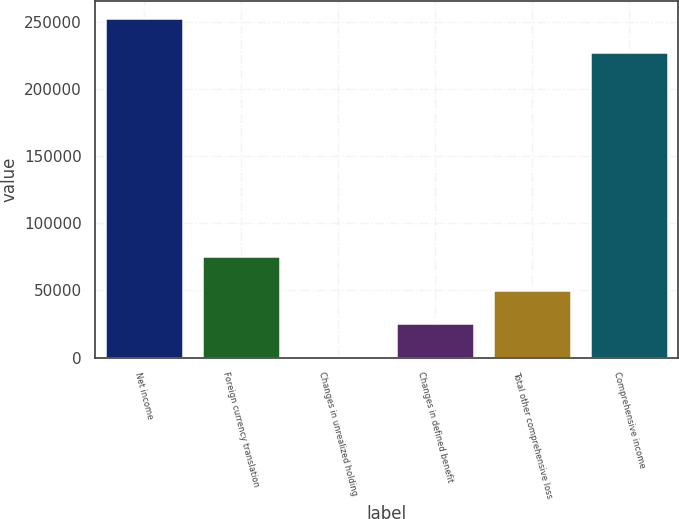<chart> <loc_0><loc_0><loc_500><loc_500><bar_chart><fcel>Net income<fcel>Foreign currency translation<fcel>Changes in unrealized holding<fcel>Changes in defined benefit<fcel>Total other comprehensive loss<fcel>Comprehensive income<nl><fcel>252870<fcel>75843.4<fcel>169<fcel>25393.8<fcel>50618.6<fcel>227645<nl></chart> 